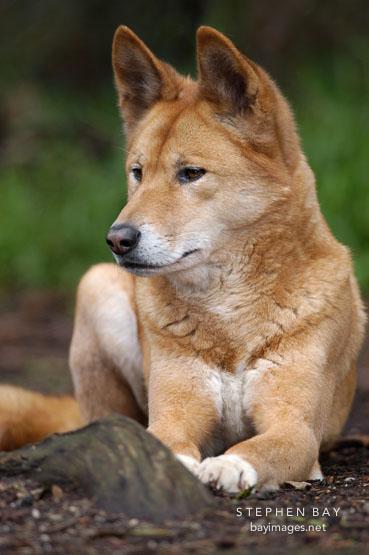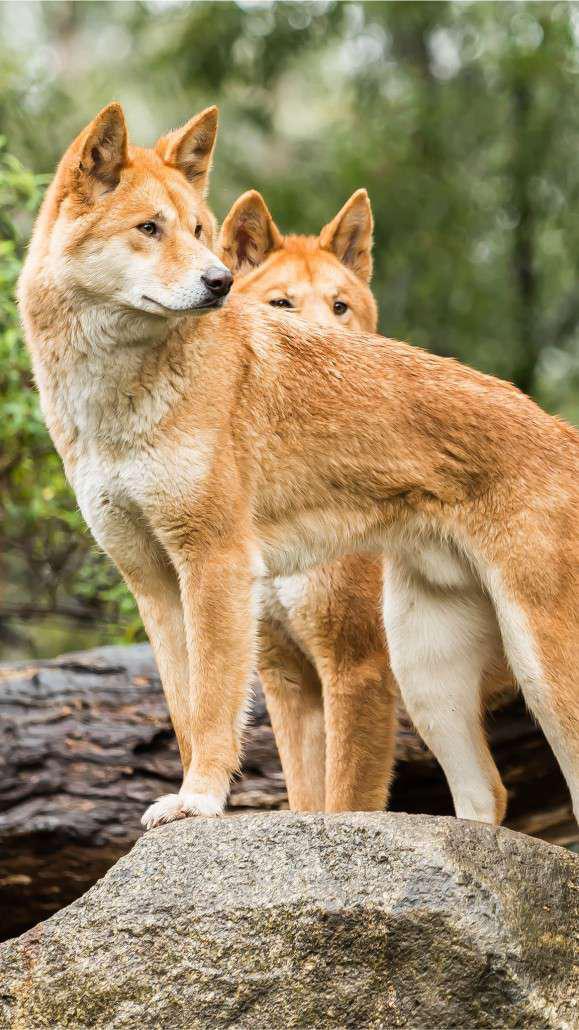The first image is the image on the left, the second image is the image on the right. Analyze the images presented: Is the assertion "A total of three canine animals are shown." valid? Answer yes or no. Yes. The first image is the image on the left, the second image is the image on the right. Given the left and right images, does the statement "There are no less than four animals" hold true? Answer yes or no. No. 